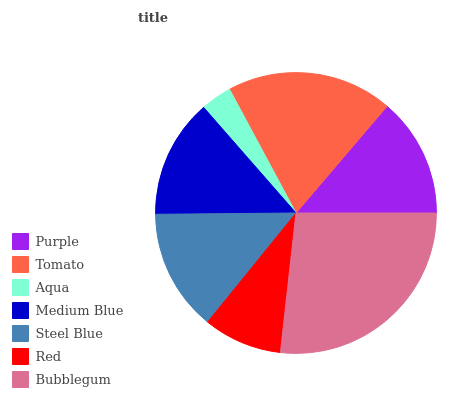Is Aqua the minimum?
Answer yes or no. Yes. Is Bubblegum the maximum?
Answer yes or no. Yes. Is Tomato the minimum?
Answer yes or no. No. Is Tomato the maximum?
Answer yes or no. No. Is Tomato greater than Purple?
Answer yes or no. Yes. Is Purple less than Tomato?
Answer yes or no. Yes. Is Purple greater than Tomato?
Answer yes or no. No. Is Tomato less than Purple?
Answer yes or no. No. Is Purple the high median?
Answer yes or no. Yes. Is Purple the low median?
Answer yes or no. Yes. Is Aqua the high median?
Answer yes or no. No. Is Medium Blue the low median?
Answer yes or no. No. 